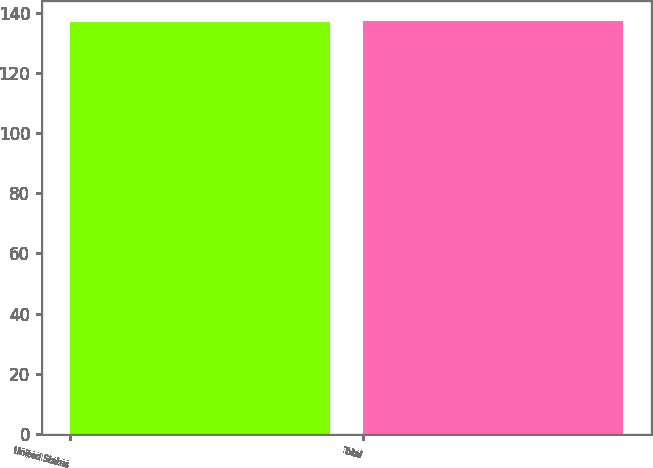Convert chart to OTSL. <chart><loc_0><loc_0><loc_500><loc_500><bar_chart><fcel>United States<fcel>Total<nl><fcel>137<fcel>137.1<nl></chart> 